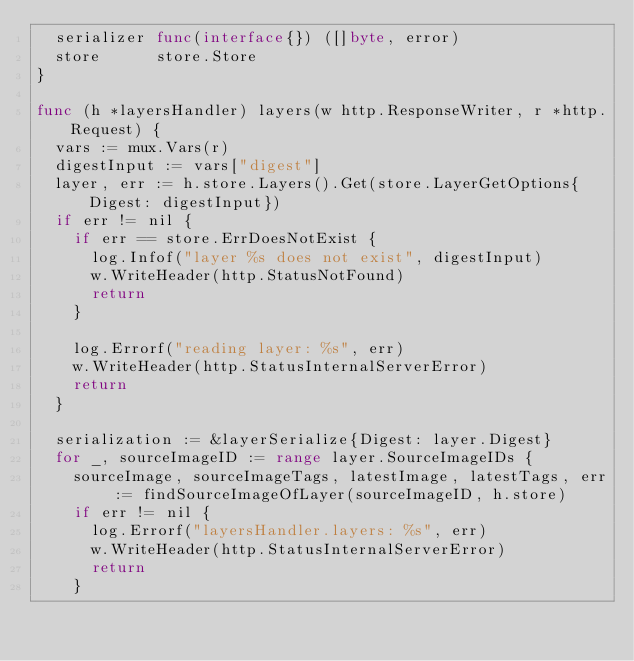<code> <loc_0><loc_0><loc_500><loc_500><_Go_>	serializer func(interface{}) ([]byte, error)
	store      store.Store
}

func (h *layersHandler) layers(w http.ResponseWriter, r *http.Request) {
	vars := mux.Vars(r)
	digestInput := vars["digest"]
	layer, err := h.store.Layers().Get(store.LayerGetOptions{Digest: digestInput})
	if err != nil {
		if err == store.ErrDoesNotExist {
			log.Infof("layer %s does not exist", digestInput)
			w.WriteHeader(http.StatusNotFound)
			return
		}

		log.Errorf("reading layer: %s", err)
		w.WriteHeader(http.StatusInternalServerError)
		return
	}

	serialization := &layerSerialize{Digest: layer.Digest}
	for _, sourceImageID := range layer.SourceImageIDs {
		sourceImage, sourceImageTags, latestImage, latestTags, err := findSourceImageOfLayer(sourceImageID, h.store)
		if err != nil {
			log.Errorf("layersHandler.layers: %s", err)
			w.WriteHeader(http.StatusInternalServerError)
			return
		}
</code> 